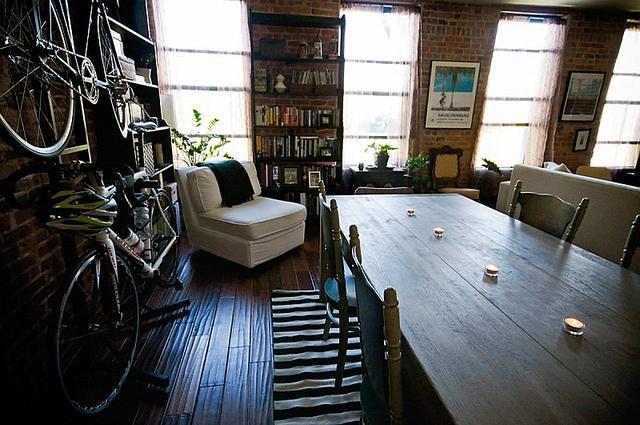How many candles are on the table?
Give a very brief answer. 4. How many couches can be seen?
Give a very brief answer. 1. How many books can be seen?
Give a very brief answer. 1. How many bicycles are in the picture?
Give a very brief answer. 2. How many dining tables are there?
Give a very brief answer. 1. How many chairs are visible?
Give a very brief answer. 4. 